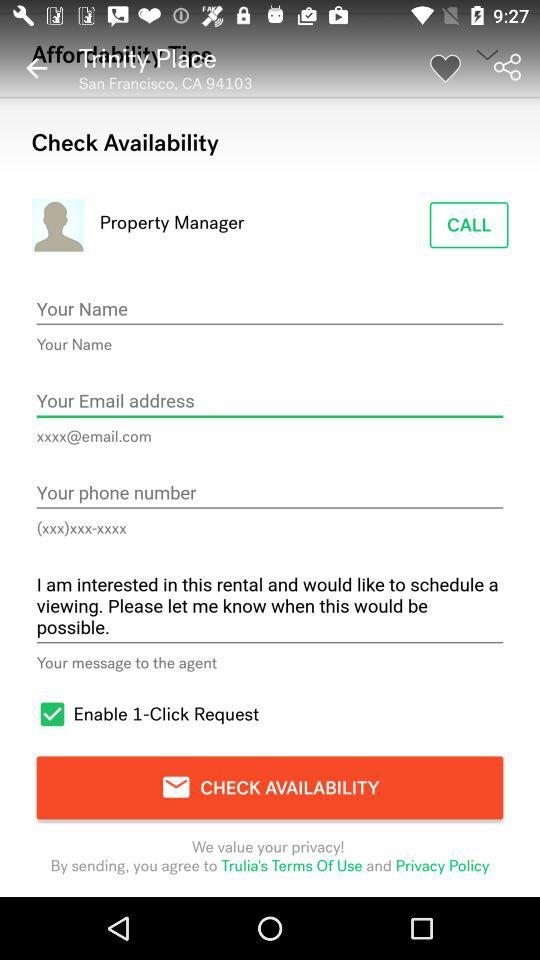What is the pincode for San Francisco? The pincode is 94103. 